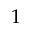<formula> <loc_0><loc_0><loc_500><loc_500>1</formula> 